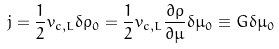<formula> <loc_0><loc_0><loc_500><loc_500>j = \frac { 1 } { 2 } v _ { c , L } \delta \rho _ { 0 } = \frac { 1 } { 2 } v _ { c , L } \frac { \partial \rho } { \partial \mu } \delta \mu _ { 0 } \equiv G \delta \mu _ { 0 }</formula> 